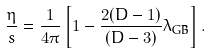Convert formula to latex. <formula><loc_0><loc_0><loc_500><loc_500>\frac { \eta } { s } = \frac { 1 } { 4 \pi } \left [ 1 - \frac { 2 ( D - 1 ) } { ( D - 3 ) } \lambda _ { \text {GB} } \right ] .</formula> 